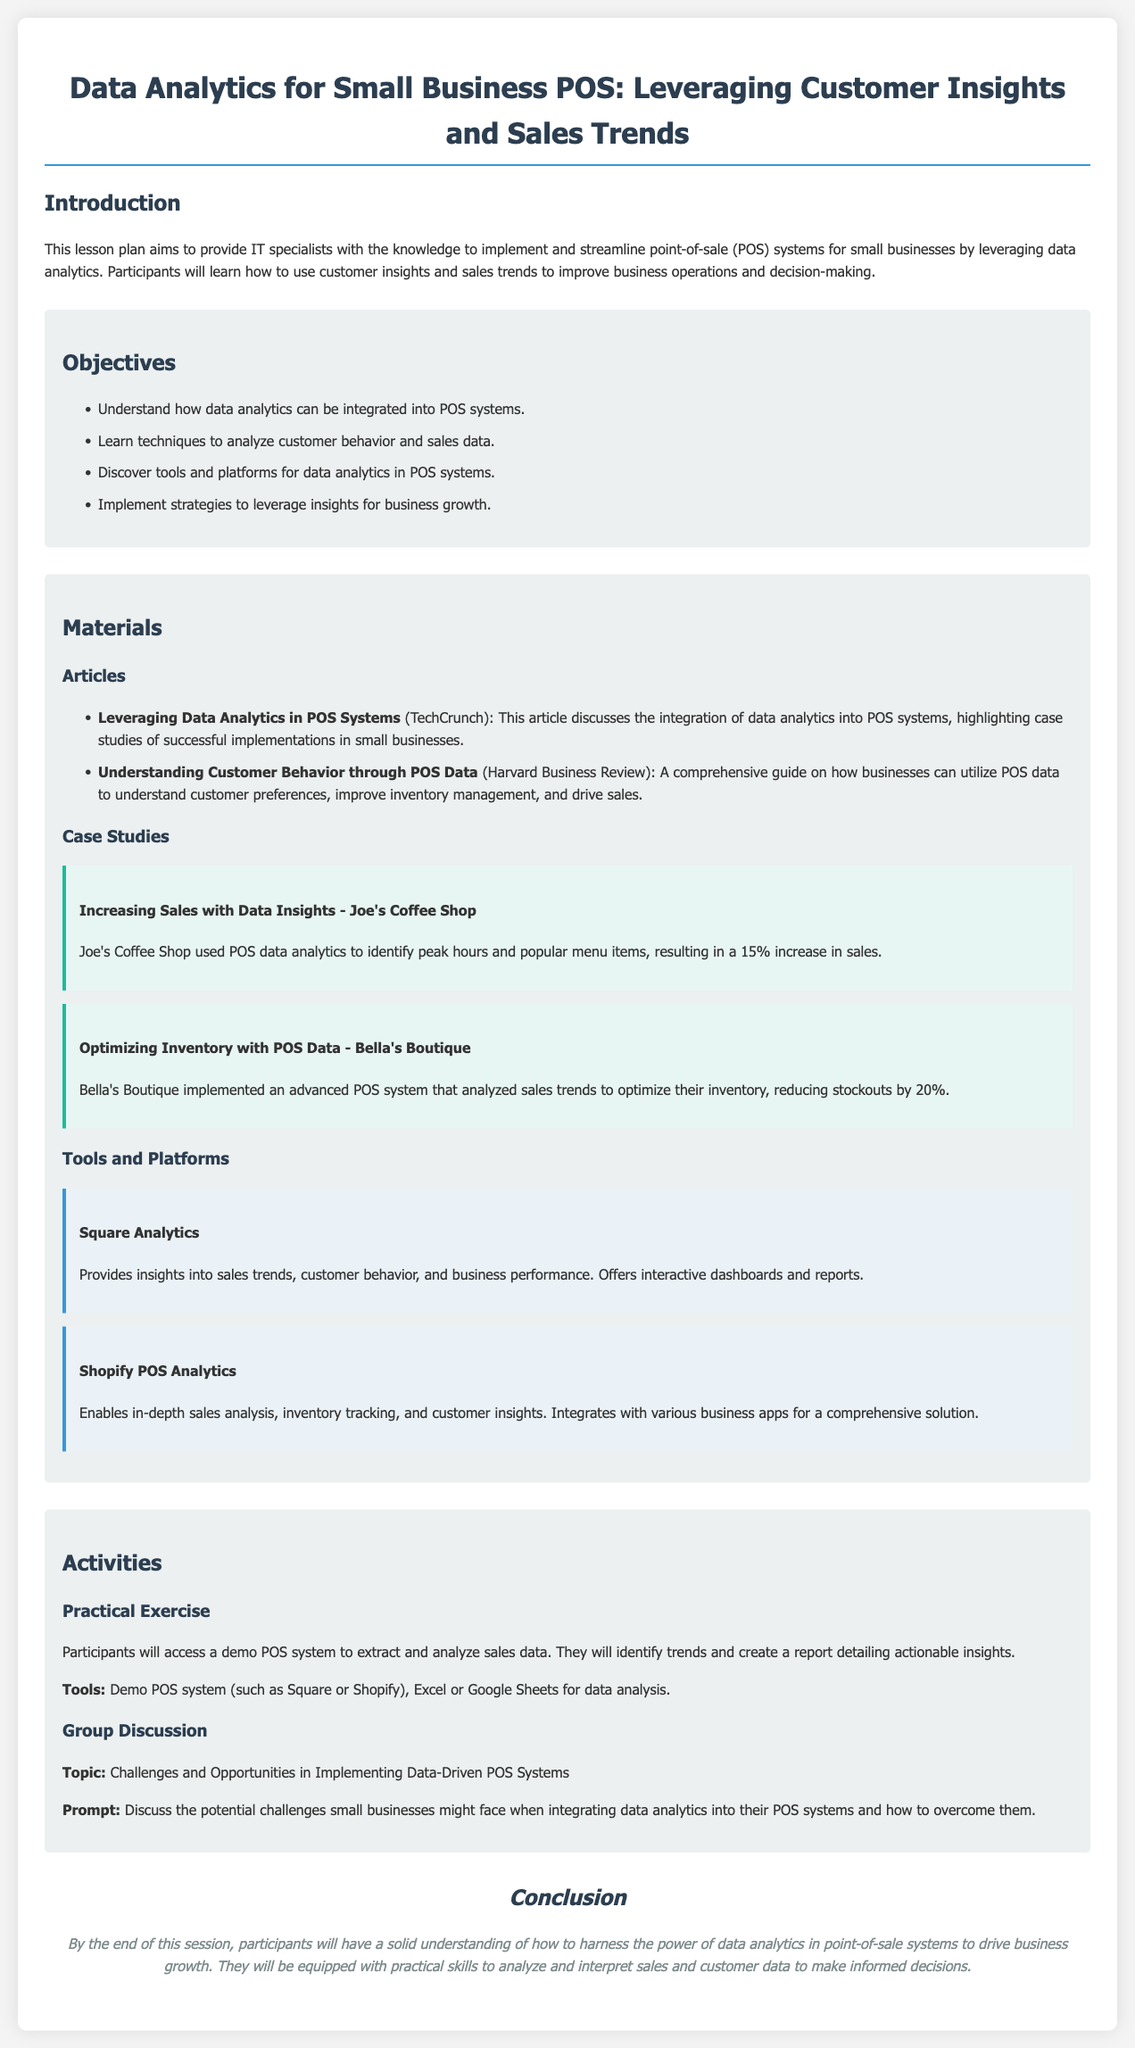What is the title of the lesson plan? The title of the lesson plan is the first heading in the document, which summarizes the focus of the content.
Answer: Data Analytics for Small Business POS: Leveraging Customer Insights and Sales Trends How many objectives are listed in the lesson plan? The objectives section lists specific learning goals for the participants, which can be counted to determine their total number.
Answer: Four What case study is included about increasing sales? The case studies provide examples of businesses utilizing data analytics, one of which is focused on sales improvement.
Answer: Increasing Sales with Data Insights - Joe's Coffee Shop What tool is mentioned for sales trend insights? The tools section includes various platforms, one of which specifically provides insights into sales trends.
Answer: Square Analytics What is the theme of the group discussion activity? The activities section outlines various engagement methods, and the group discussion has a specific topic related to the session's focus.
Answer: Challenges and Opportunities in Implementing Data-Driven POS Systems What was the percentage increase in sales at Joe's Coffee Shop? The case study mentions specific outcomes from using data analytics, allowing for the calculation of sales increase percentage.
Answer: Fifteen percent What is mentioned as a material from Harvard Business Review? The materials section contains articles that participants will review, including a specific source from a notable publication.
Answer: Understanding Customer Behavior through POS Data What is the main aim of the lesson plan? The introduction outlines the overall goal of the lesson plan succinctly, providing clarity on the intended outcomes for participants.
Answer: Knowledge to implement and streamline point-of-sale (POS) systems for small businesses 